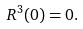<formula> <loc_0><loc_0><loc_500><loc_500>R ^ { 3 } ( 0 ) = 0 .</formula> 